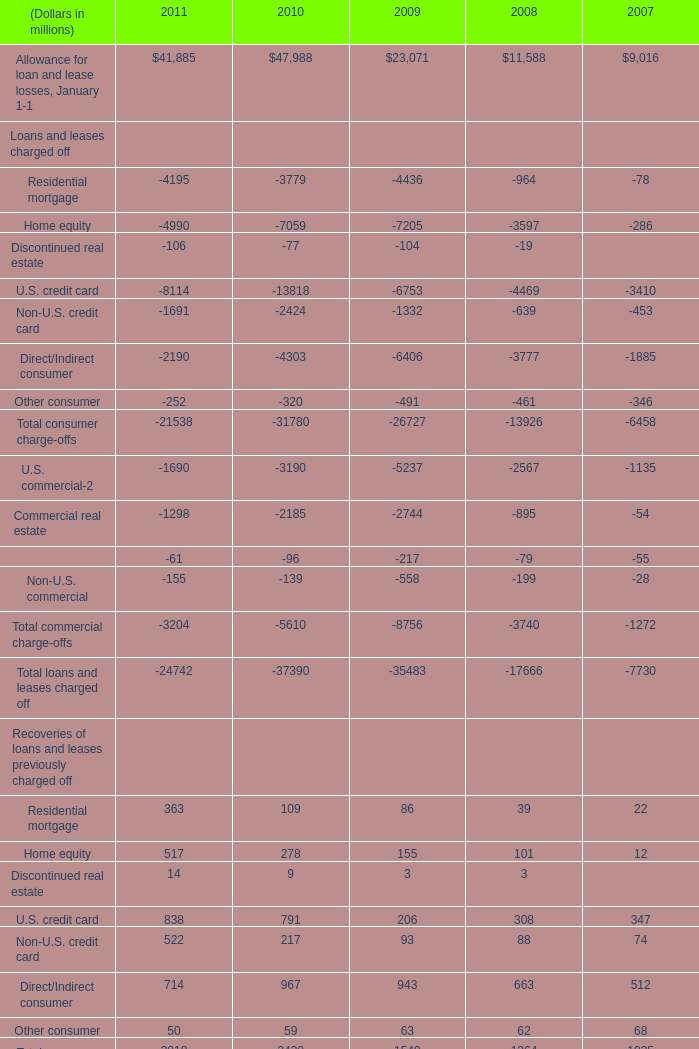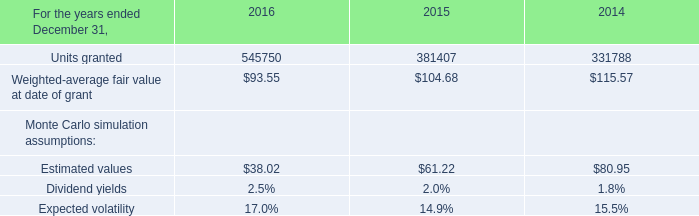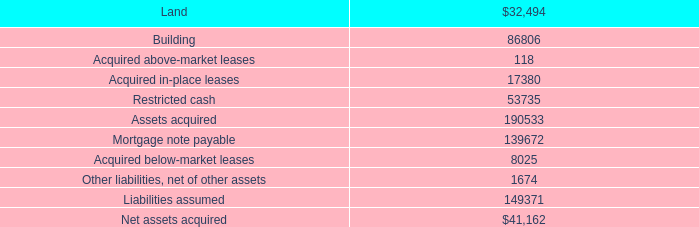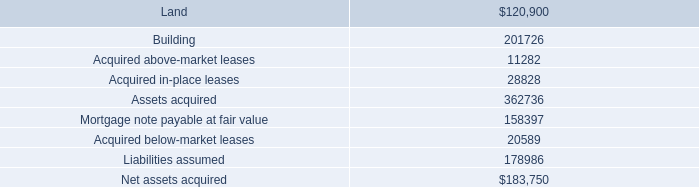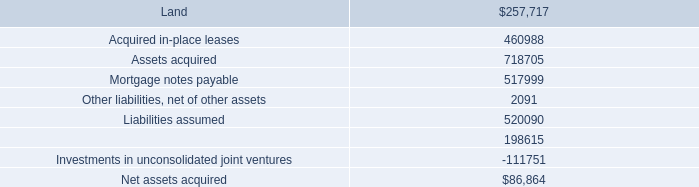How many consumer recoveries exceed the average of commercial recoveries in 2011? 
Answer: 5. 